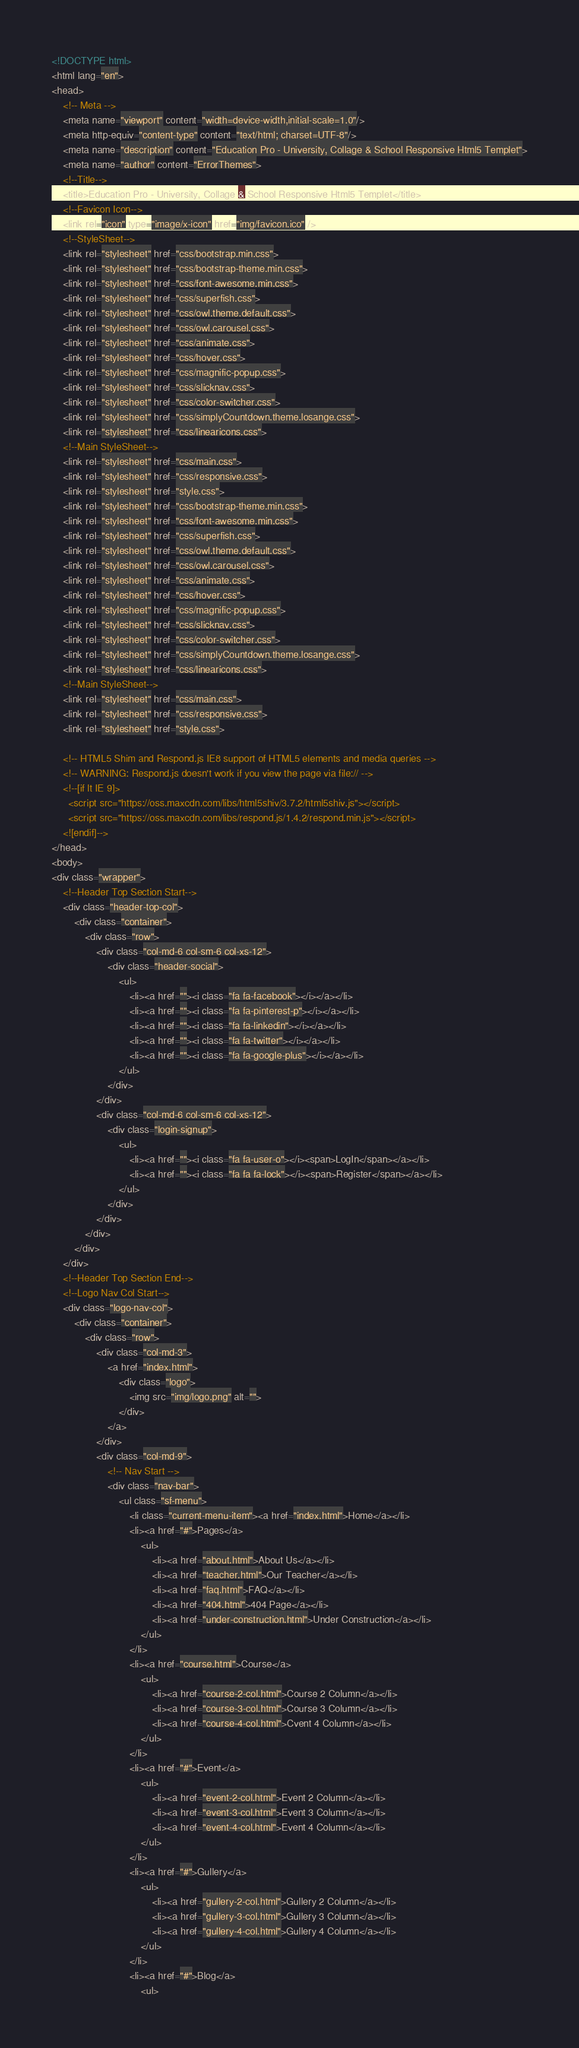Convert code to text. <code><loc_0><loc_0><loc_500><loc_500><_HTML_><!DOCTYPE html>
<html lang="en">
<head>
	<!-- Meta -->
	<meta name="viewport" content="width=device-width,initial-scale=1.0"/>
	<meta http-equiv="content-type" content="text/html; charset=UTF-8"/>
	<meta name="description" content="Education Pro - University, Collage & School Responsive Html5 Templet">
	<meta name="author" content="ErrorThemes">
	<!--Title-->
	<title>Education Pro - University, Collage & School Responsive Html5 Templet</title>
	<!--Favicon Icon-->
	<link rel="icon" type="image/x-icon" href="img/favicon.ico" />
	<!--StyleSheet-->
	<link rel="stylesheet" href="css/bootstrap.min.css">
	<link rel="stylesheet" href="css/bootstrap-theme.min.css">
	<link rel="stylesheet" href="css/font-awesome.min.css">
	<link rel="stylesheet" href="css/superfish.css">
	<link rel="stylesheet" href="css/owl.theme.default.css">
	<link rel="stylesheet" href="css/owl.carousel.css">
	<link rel="stylesheet" href="css/animate.css">
	<link rel="stylesheet" href="css/hover.css">
	<link rel="stylesheet" href="css/magnific-popup.css">
	<link rel="stylesheet" href="css/slicknav.css">
	<link rel="stylesheet" href="css/color-switcher.css">
	<link rel="stylesheet" href="css/simplyCountdown.theme.losange.css">
	<link rel="stylesheet" href="css/linearicons.css">
	<!--Main StyleSheet-->
	<link rel="stylesheet" href="css/main.css">
	<link rel="stylesheet" href="css/responsive.css">
	<link rel="stylesheet" href="style.css">
	<link rel="stylesheet" href="css/bootstrap-theme.min.css">
	<link rel="stylesheet" href="css/font-awesome.min.css">
	<link rel="stylesheet" href="css/superfish.css">
	<link rel="stylesheet" href="css/owl.theme.default.css">
	<link rel="stylesheet" href="css/owl.carousel.css">
	<link rel="stylesheet" href="css/animate.css">
	<link rel="stylesheet" href="css/hover.css">
	<link rel="stylesheet" href="css/magnific-popup.css">
	<link rel="stylesheet" href="css/slicknav.css">
	<link rel="stylesheet" href="css/color-switcher.css">
	<link rel="stylesheet" href="css/simplyCountdown.theme.losange.css">
	<link rel="stylesheet" href="css/linearicons.css">
	<!--Main StyleSheet-->
	<link rel="stylesheet" href="css/main.css">
	<link rel="stylesheet" href="css/responsive.css">
	<link rel="stylesheet" href="style.css">
	
	<!-- HTML5 Shim and Respond.js IE8 support of HTML5 elements and media queries -->
    <!-- WARNING: Respond.js doesn't work if you view the page via file:// -->
    <!--[if lt IE 9]>
      <script src="https://oss.maxcdn.com/libs/html5shiv/3.7.2/html5shiv.js"></script>
      <script src="https://oss.maxcdn.com/libs/respond.js/1.4.2/respond.min.js"></script>
    <![endif]-->
</head>
<body>
<div class="wrapper">
	<!--Header Top Section Start-->
	<div class="header-top-col">
		<div class="container">
			<div class="row">
				<div class="col-md-6 col-sm-6 col-xs-12">
					<div class="header-social">
						<ul>
							<li><a href=""><i class="fa fa-facebook"></i></a></li>
							<li><a href=""><i class="fa fa-pinterest-p"></i></a></li>
							<li><a href=""><i class="fa fa-linkedin"></i></a></li>
							<li><a href=""><i class="fa fa-twitter"></i></a></li>
							<li><a href=""><i class="fa fa-google-plus"></i></a></li>
						</ul>
					</div>
				</div>
				<div class="col-md-6 col-sm-6 col-xs-12">
					<div class="login-signup">
						<ul>
							<li><a href=""><i class="fa fa-user-o"></i><span>LogIn</span></a></li>
							<li><a href=""><i class="fa fa fa-lock"></i><span>Register</span></a></li>
						</ul>
					</div>
				</div>
			</div>
		</div>
	</div>
	<!--Header Top Section End-->
	<!--Logo Nav Col Start-->
	<div class="logo-nav-col">
		<div class="container">
			<div class="row">
				<div class="col-md-3">
					<a href="index.html">
						<div class="logo">
							<img src="img/logo.png" alt="">
						</div>
					</a>	
				</div>
				<div class="col-md-9">
					<!-- Nav Start -->
					<div class="nav-bar">
						<ul class="sf-menu">
							<li class="current-menu-item"><a href="index.html">Home</a></li>
							<li><a href="#">Pages</a>
								<ul>
									<li><a href="about.html">About Us</a></li>
									<li><a href="teacher.html">Our Teacher</a></li>
									<li><a href="faq.html">FAQ</a></li>
									<li><a href="404.html">404 Page</a></li>
									<li><a href="under-construction.html">Under Construction</a></li>
								</ul>
							</li>
							<li><a href="course.html">Course</a>
								<ul>
									<li><a href="course-2-col.html">Course 2 Column</a></li>
									<li><a href="course-3-col.html">Course 3 Column</a></li>
									<li><a href="course-4-col.html">Cvent 4 Column</a></li>
								</ul>
							</li>
							<li><a href="#">Event</a>
								<ul>
									<li><a href="event-2-col.html">Event 2 Column</a></li>
									<li><a href="event-3-col.html">Event 3 Column</a></li>
									<li><a href="event-4-col.html">Event 4 Column</a></li>
								</ul>
							</li>
							<li><a href="#">Gullery</a>
								<ul>
									<li><a href="gullery-2-col.html">Gullery 2 Column</a></li>
									<li><a href="gullery-3-col.html">Gullery 3 Column</a></li>
									<li><a href="gullery-4-col.html">Gullery 4 Column</a></li>
								</ul>
							</li>
							<li><a href="#">Blog</a>
								<ul></code> 